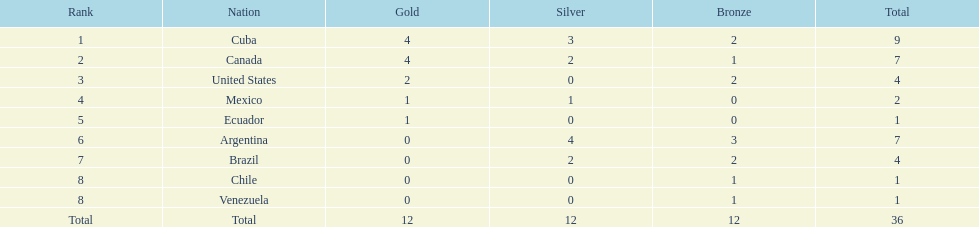Who had more silver medals, cuba or brazil? Cuba. Would you be able to parse every entry in this table? {'header': ['Rank', 'Nation', 'Gold', 'Silver', 'Bronze', 'Total'], 'rows': [['1', 'Cuba', '4', '3', '2', '9'], ['2', 'Canada', '4', '2', '1', '7'], ['3', 'United States', '2', '0', '2', '4'], ['4', 'Mexico', '1', '1', '0', '2'], ['5', 'Ecuador', '1', '0', '0', '1'], ['6', 'Argentina', '0', '4', '3', '7'], ['7', 'Brazil', '0', '2', '2', '4'], ['8', 'Chile', '0', '0', '1', '1'], ['8', 'Venezuela', '0', '0', '1', '1'], ['Total', 'Total', '12', '12', '12', '36']]} 